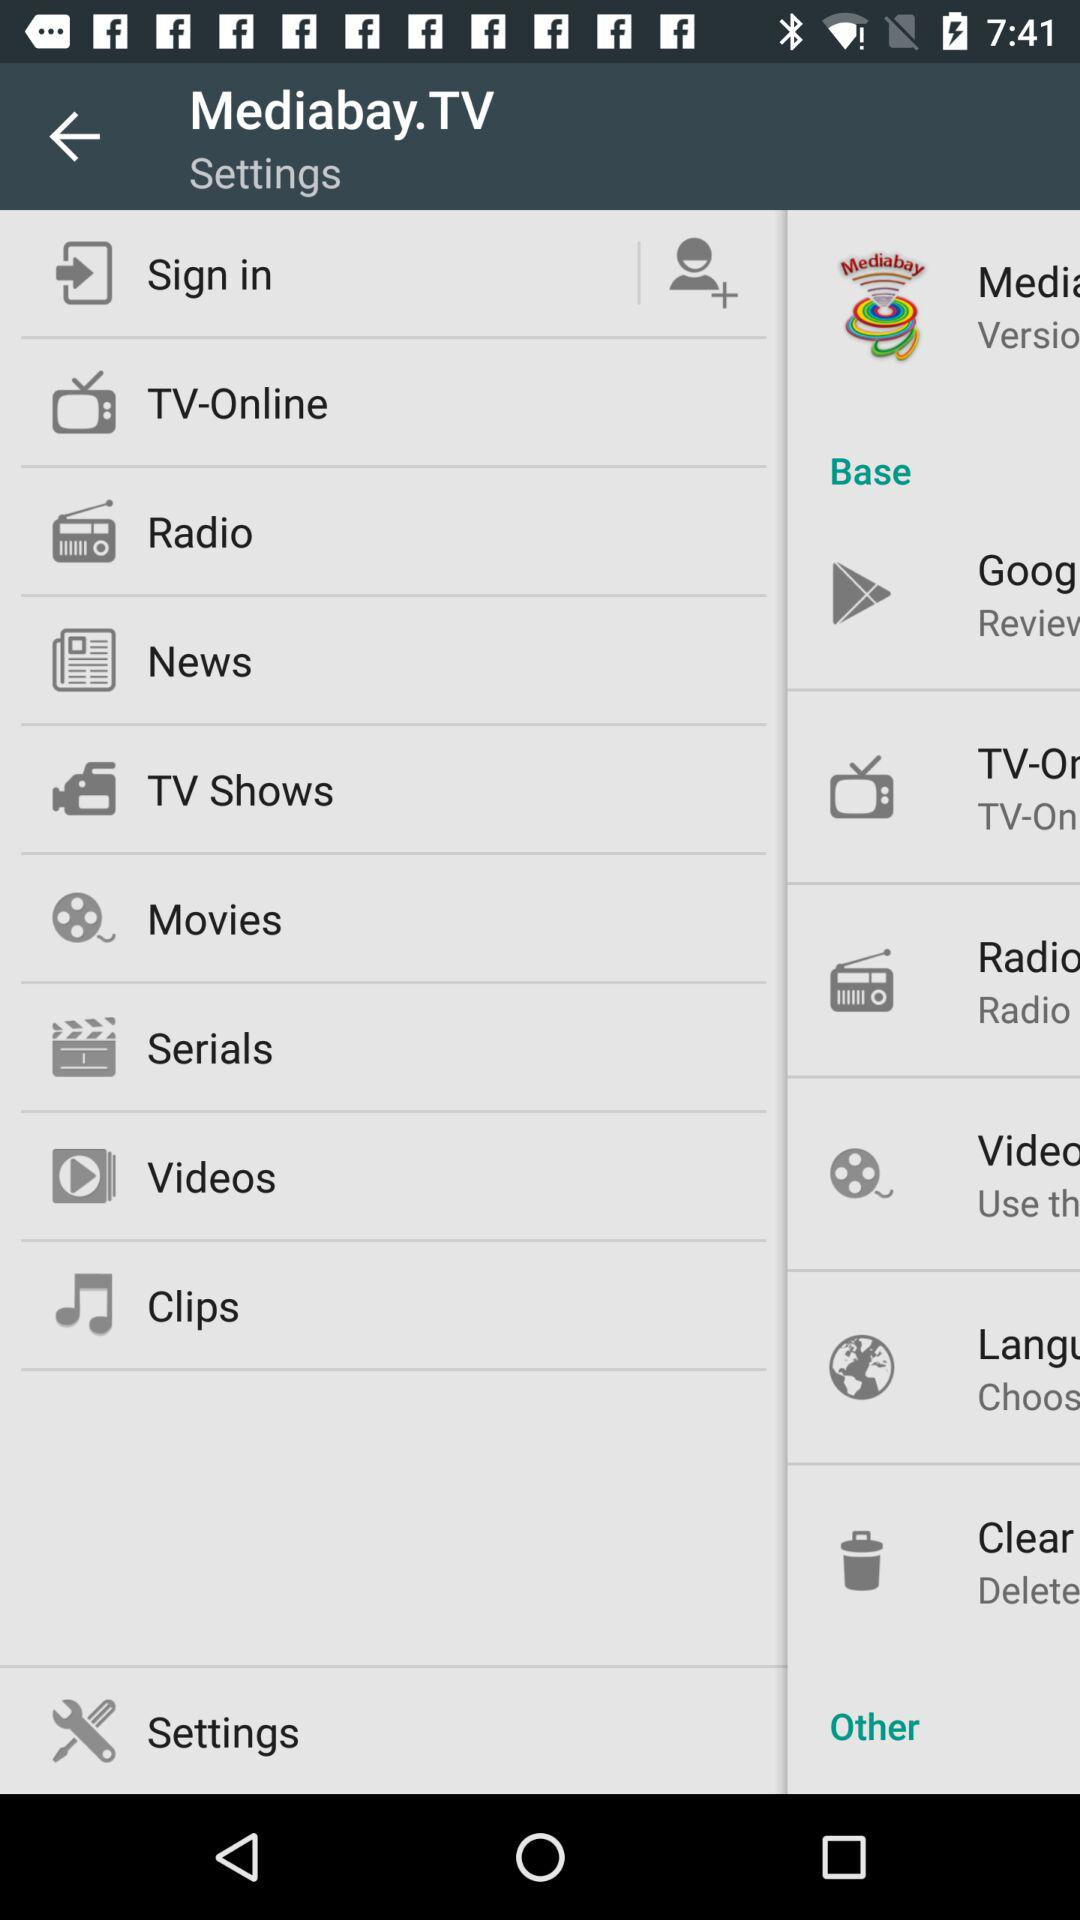How many notifications are there in "Settings"?
When the provided information is insufficient, respond with <no answer>. <no answer> 